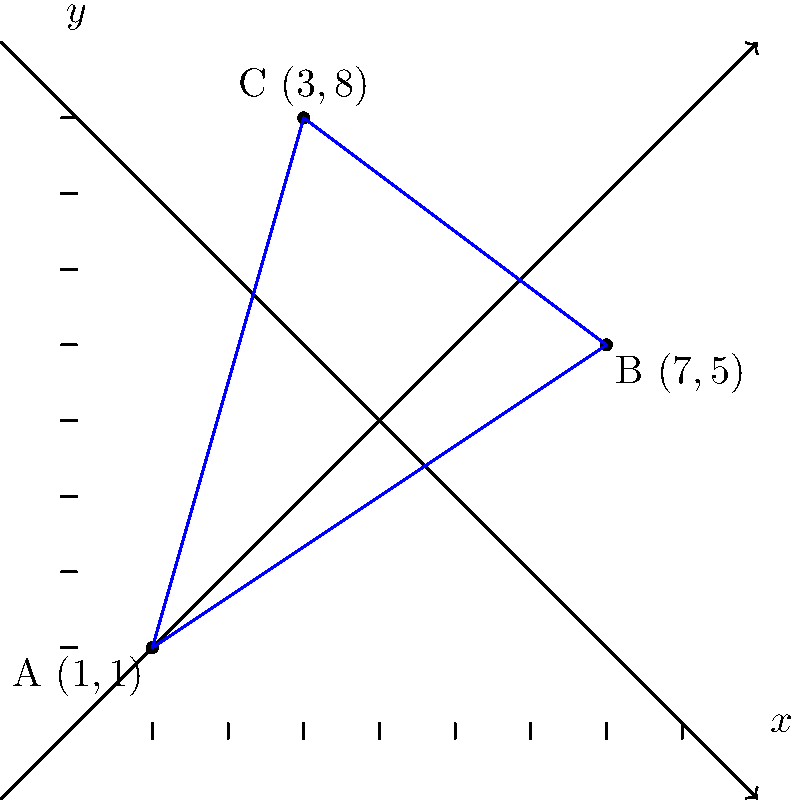In a children's picture book, three eye-catching illustrations are placed at different points on a coordinate plane to form a triangle. The illustrator has chosen vibrant colors for each point: A (red), B (yellow), and C (blue). If the coordinates of these illustrations are A(1,1), B(7,5), and C(3,8), calculate the area of the triangle formed by these points. How might this arrangement and the resulting shape contribute to the visual appeal and engagement of young readers? To find the area of the triangle, we'll use the formula for the area of a triangle given the coordinates of its vertices:

Area = $\frac{1}{2}|x_1(y_2 - y_3) + x_2(y_3 - y_1) + x_3(y_1 - y_2)|$

Where $(x_1, y_1)$, $(x_2, y_2)$, and $(x_3, y_3)$ are the coordinates of the three vertices.

Step 1: Identify the coordinates
A(1,1), B(7,5), C(3,8)

Step 2: Plug the coordinates into the formula
Area = $\frac{1}{2}|1(5 - 8) + 7(8 - 1) + 3(1 - 5)|$

Step 3: Simplify the expressions inside the parentheses
Area = $\frac{1}{2}|1(-3) + 7(7) + 3(-4)|$

Step 4: Multiply
Area = $\frac{1}{2}|-3 + 49 - 12|$

Step 5: Add the terms inside the absolute value signs
Area = $\frac{1}{2}|34|$

Step 6: Calculate the final result
Area = $\frac{1}{2} \cdot 34 = 17$

The arrangement of these illustrations forms a large, asymmetrical triangle that spans a significant portion of the coordinate plane. This layout can contribute to the visual appeal and engagement of young readers in several ways:

1. The vibrant colors (red, yellow, blue) at each point create a visually striking contrast, drawing the reader's attention.
2. The asymmetry of the triangle adds visual interest and dynamism to the page layout.
3. The large size of the triangle allows for ample space to incorporate detailed illustrations at each point, encouraging exploration of the page.
4. The diagonal lines of the triangle can guide the reader's eye across the page, potentially aiding in the flow of the narrative.
5. The use of a geometric shape (triangle) introduces basic mathematical concepts in a visually appealing way, potentially sparking interest in shapes and spatial relationships.
Answer: 17 square units 